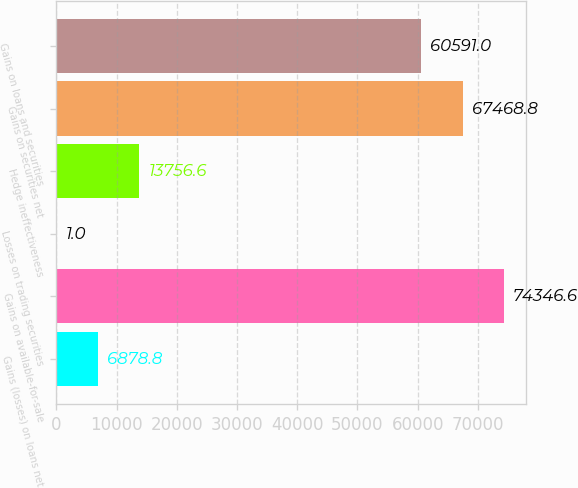Convert chart. <chart><loc_0><loc_0><loc_500><loc_500><bar_chart><fcel>Gains (losses) on loans net<fcel>Gains on available-for-sale<fcel>Losses on trading securities<fcel>Hedge ineffectiveness<fcel>Gains on securities net<fcel>Gains on loans and securities<nl><fcel>6878.8<fcel>74346.6<fcel>1<fcel>13756.6<fcel>67468.8<fcel>60591<nl></chart> 